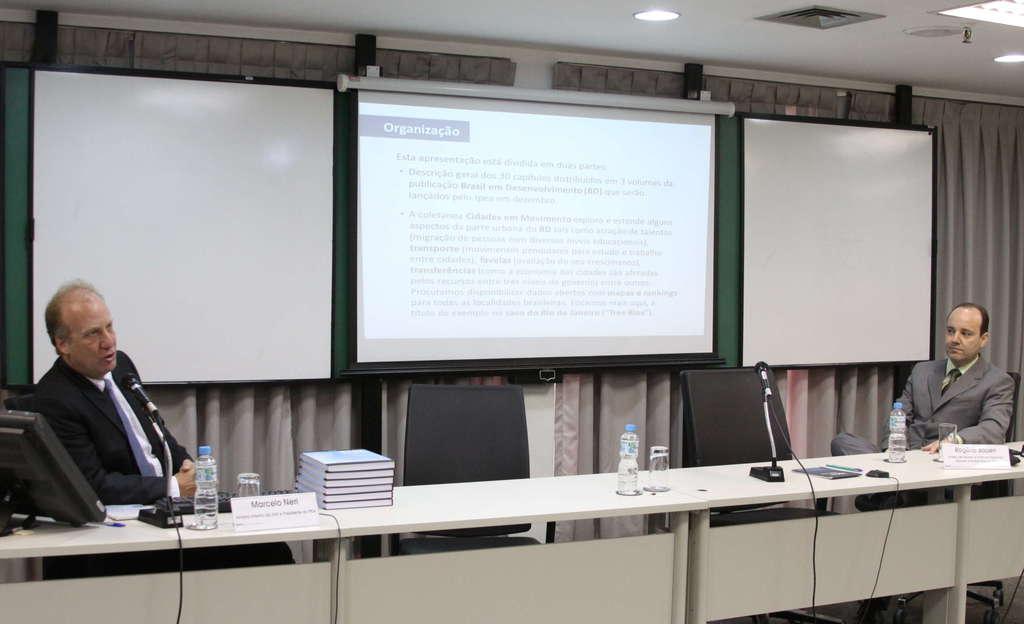In one or two sentences, can you explain what this image depicts? we can see two men sitting on chair. This is a table, book, glass, water bottle and microphones. Back of them there is a white screen. 